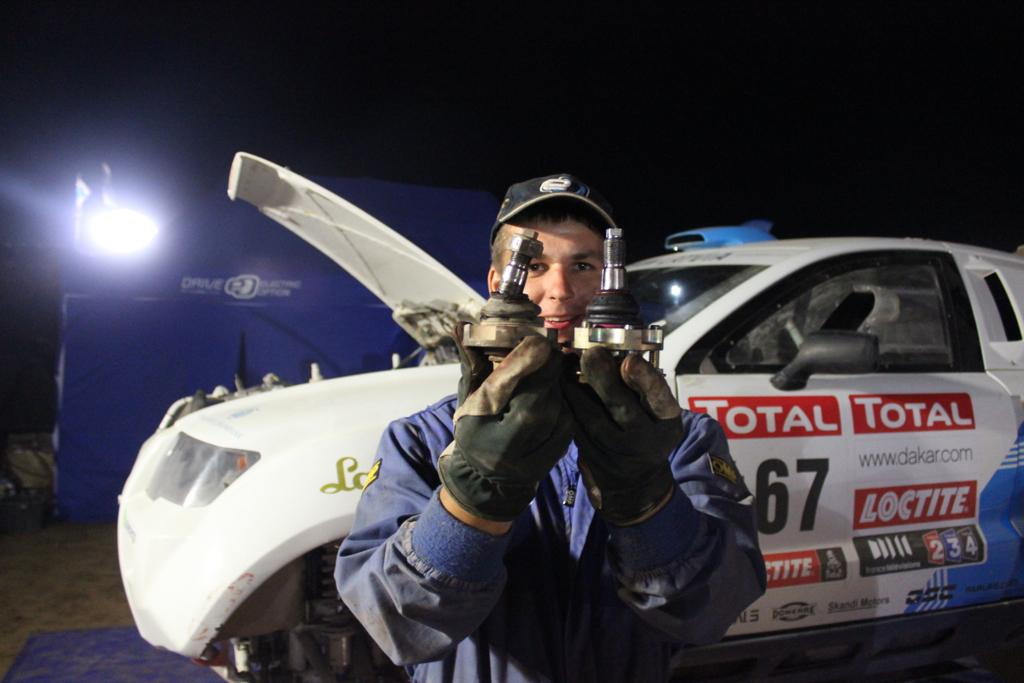What is the person in the image holding? The facts do not specify what the person is holding. What can be seen in the background of the image? There is a vehicle, a light source, and a blue color banner visible in the background. Can you describe the lighting conditions in the image? The image appears to be dark. Where is the duck located in the image? There is no duck present in the image. What is the person holding on the earth in the image? The facts do not specify what the person is holding or if the image is related to the earth. 